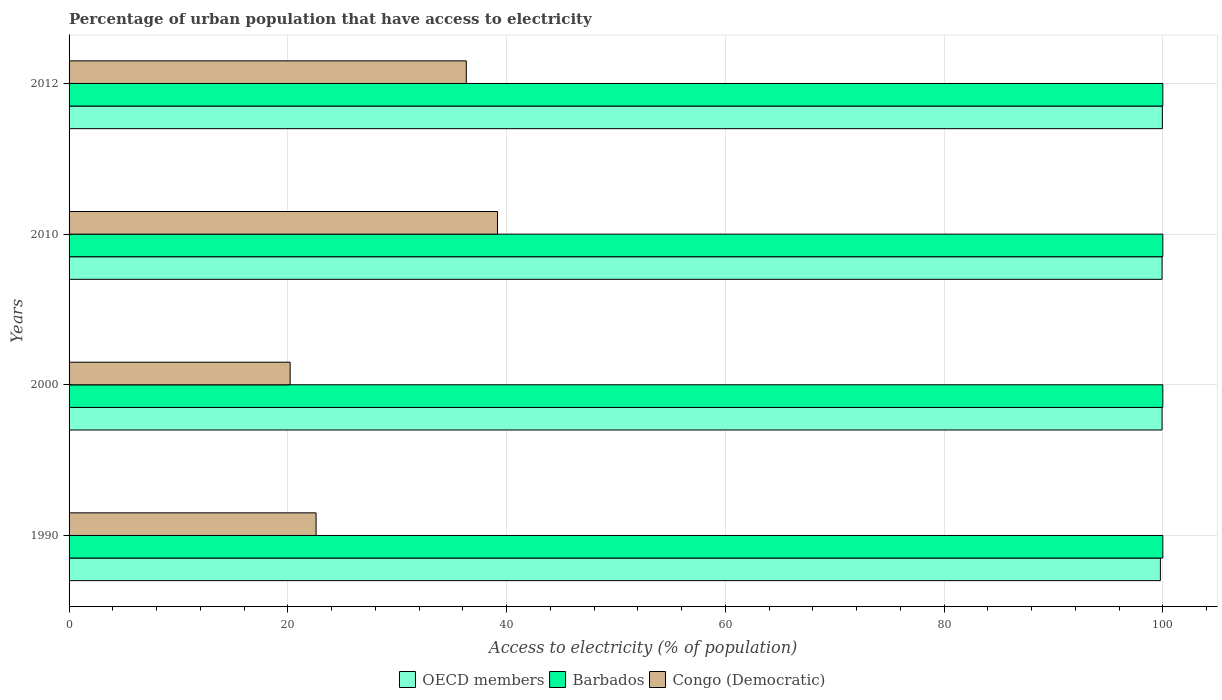How many different coloured bars are there?
Give a very brief answer. 3. How many groups of bars are there?
Your answer should be compact. 4. Are the number of bars per tick equal to the number of legend labels?
Provide a succinct answer. Yes. How many bars are there on the 2nd tick from the top?
Offer a very short reply. 3. What is the label of the 3rd group of bars from the top?
Make the answer very short. 2000. What is the percentage of urban population that have access to electricity in OECD members in 1990?
Make the answer very short. 99.78. Across all years, what is the maximum percentage of urban population that have access to electricity in Barbados?
Offer a terse response. 100. Across all years, what is the minimum percentage of urban population that have access to electricity in Barbados?
Provide a short and direct response. 100. What is the total percentage of urban population that have access to electricity in Congo (Democratic) in the graph?
Provide a short and direct response. 118.29. What is the difference between the percentage of urban population that have access to electricity in Congo (Democratic) in 1990 and that in 2000?
Provide a succinct answer. 2.37. What is the difference between the percentage of urban population that have access to electricity in Congo (Democratic) in 1990 and the percentage of urban population that have access to electricity in Barbados in 2000?
Keep it short and to the point. -77.42. What is the average percentage of urban population that have access to electricity in Congo (Democratic) per year?
Offer a very short reply. 29.57. In the year 2000, what is the difference between the percentage of urban population that have access to electricity in Barbados and percentage of urban population that have access to electricity in Congo (Democratic)?
Offer a very short reply. 79.79. Is the percentage of urban population that have access to electricity in Barbados in 2000 less than that in 2012?
Keep it short and to the point. No. What is the difference between the highest and the second highest percentage of urban population that have access to electricity in OECD members?
Your response must be concise. 0.03. What is the difference between the highest and the lowest percentage of urban population that have access to electricity in OECD members?
Give a very brief answer. 0.18. In how many years, is the percentage of urban population that have access to electricity in Barbados greater than the average percentage of urban population that have access to electricity in Barbados taken over all years?
Ensure brevity in your answer.  0. What does the 2nd bar from the top in 2010 represents?
Your answer should be compact. Barbados. How many bars are there?
Provide a succinct answer. 12. Are all the bars in the graph horizontal?
Your response must be concise. Yes. How many years are there in the graph?
Make the answer very short. 4. What is the difference between two consecutive major ticks on the X-axis?
Your answer should be very brief. 20. Are the values on the major ticks of X-axis written in scientific E-notation?
Your answer should be very brief. No. Does the graph contain any zero values?
Offer a very short reply. No. What is the title of the graph?
Your response must be concise. Percentage of urban population that have access to electricity. What is the label or title of the X-axis?
Your response must be concise. Access to electricity (% of population). What is the Access to electricity (% of population) of OECD members in 1990?
Give a very brief answer. 99.78. What is the Access to electricity (% of population) in Barbados in 1990?
Make the answer very short. 100. What is the Access to electricity (% of population) of Congo (Democratic) in 1990?
Give a very brief answer. 22.58. What is the Access to electricity (% of population) in OECD members in 2000?
Provide a succinct answer. 99.93. What is the Access to electricity (% of population) in Barbados in 2000?
Your response must be concise. 100. What is the Access to electricity (% of population) of Congo (Democratic) in 2000?
Offer a terse response. 20.21. What is the Access to electricity (% of population) of OECD members in 2010?
Your answer should be compact. 99.93. What is the Access to electricity (% of population) in Congo (Democratic) in 2010?
Your answer should be very brief. 39.17. What is the Access to electricity (% of population) of OECD members in 2012?
Ensure brevity in your answer.  99.96. What is the Access to electricity (% of population) in Barbados in 2012?
Offer a terse response. 100. What is the Access to electricity (% of population) of Congo (Democratic) in 2012?
Ensure brevity in your answer.  36.32. Across all years, what is the maximum Access to electricity (% of population) of OECD members?
Ensure brevity in your answer.  99.96. Across all years, what is the maximum Access to electricity (% of population) of Congo (Democratic)?
Keep it short and to the point. 39.17. Across all years, what is the minimum Access to electricity (% of population) of OECD members?
Offer a very short reply. 99.78. Across all years, what is the minimum Access to electricity (% of population) in Barbados?
Your answer should be very brief. 100. Across all years, what is the minimum Access to electricity (% of population) of Congo (Democratic)?
Ensure brevity in your answer.  20.21. What is the total Access to electricity (% of population) of OECD members in the graph?
Provide a short and direct response. 399.6. What is the total Access to electricity (% of population) in Congo (Democratic) in the graph?
Provide a succinct answer. 118.29. What is the difference between the Access to electricity (% of population) of OECD members in 1990 and that in 2000?
Give a very brief answer. -0.15. What is the difference between the Access to electricity (% of population) in Congo (Democratic) in 1990 and that in 2000?
Provide a succinct answer. 2.37. What is the difference between the Access to electricity (% of population) in OECD members in 1990 and that in 2010?
Give a very brief answer. -0.15. What is the difference between the Access to electricity (% of population) in Barbados in 1990 and that in 2010?
Keep it short and to the point. 0. What is the difference between the Access to electricity (% of population) in Congo (Democratic) in 1990 and that in 2010?
Ensure brevity in your answer.  -16.59. What is the difference between the Access to electricity (% of population) of OECD members in 1990 and that in 2012?
Your answer should be very brief. -0.18. What is the difference between the Access to electricity (% of population) in Congo (Democratic) in 1990 and that in 2012?
Provide a short and direct response. -13.73. What is the difference between the Access to electricity (% of population) in OECD members in 2000 and that in 2010?
Keep it short and to the point. -0. What is the difference between the Access to electricity (% of population) in Congo (Democratic) in 2000 and that in 2010?
Ensure brevity in your answer.  -18.96. What is the difference between the Access to electricity (% of population) of OECD members in 2000 and that in 2012?
Offer a very short reply. -0.03. What is the difference between the Access to electricity (% of population) in Barbados in 2000 and that in 2012?
Your answer should be very brief. 0. What is the difference between the Access to electricity (% of population) in Congo (Democratic) in 2000 and that in 2012?
Keep it short and to the point. -16.11. What is the difference between the Access to electricity (% of population) of OECD members in 2010 and that in 2012?
Offer a very short reply. -0.03. What is the difference between the Access to electricity (% of population) in Barbados in 2010 and that in 2012?
Provide a succinct answer. 0. What is the difference between the Access to electricity (% of population) of Congo (Democratic) in 2010 and that in 2012?
Your answer should be very brief. 2.86. What is the difference between the Access to electricity (% of population) of OECD members in 1990 and the Access to electricity (% of population) of Barbados in 2000?
Make the answer very short. -0.22. What is the difference between the Access to electricity (% of population) of OECD members in 1990 and the Access to electricity (% of population) of Congo (Democratic) in 2000?
Your response must be concise. 79.57. What is the difference between the Access to electricity (% of population) of Barbados in 1990 and the Access to electricity (% of population) of Congo (Democratic) in 2000?
Offer a terse response. 79.79. What is the difference between the Access to electricity (% of population) in OECD members in 1990 and the Access to electricity (% of population) in Barbados in 2010?
Provide a short and direct response. -0.22. What is the difference between the Access to electricity (% of population) in OECD members in 1990 and the Access to electricity (% of population) in Congo (Democratic) in 2010?
Keep it short and to the point. 60.61. What is the difference between the Access to electricity (% of population) in Barbados in 1990 and the Access to electricity (% of population) in Congo (Democratic) in 2010?
Provide a short and direct response. 60.83. What is the difference between the Access to electricity (% of population) in OECD members in 1990 and the Access to electricity (% of population) in Barbados in 2012?
Make the answer very short. -0.22. What is the difference between the Access to electricity (% of population) of OECD members in 1990 and the Access to electricity (% of population) of Congo (Democratic) in 2012?
Offer a terse response. 63.46. What is the difference between the Access to electricity (% of population) in Barbados in 1990 and the Access to electricity (% of population) in Congo (Democratic) in 2012?
Provide a short and direct response. 63.68. What is the difference between the Access to electricity (% of population) of OECD members in 2000 and the Access to electricity (% of population) of Barbados in 2010?
Give a very brief answer. -0.07. What is the difference between the Access to electricity (% of population) in OECD members in 2000 and the Access to electricity (% of population) in Congo (Democratic) in 2010?
Offer a terse response. 60.76. What is the difference between the Access to electricity (% of population) in Barbados in 2000 and the Access to electricity (% of population) in Congo (Democratic) in 2010?
Ensure brevity in your answer.  60.83. What is the difference between the Access to electricity (% of population) in OECD members in 2000 and the Access to electricity (% of population) in Barbados in 2012?
Make the answer very short. -0.07. What is the difference between the Access to electricity (% of population) in OECD members in 2000 and the Access to electricity (% of population) in Congo (Democratic) in 2012?
Ensure brevity in your answer.  63.61. What is the difference between the Access to electricity (% of population) of Barbados in 2000 and the Access to electricity (% of population) of Congo (Democratic) in 2012?
Offer a terse response. 63.68. What is the difference between the Access to electricity (% of population) of OECD members in 2010 and the Access to electricity (% of population) of Barbados in 2012?
Offer a very short reply. -0.07. What is the difference between the Access to electricity (% of population) of OECD members in 2010 and the Access to electricity (% of population) of Congo (Democratic) in 2012?
Give a very brief answer. 63.62. What is the difference between the Access to electricity (% of population) of Barbados in 2010 and the Access to electricity (% of population) of Congo (Democratic) in 2012?
Make the answer very short. 63.68. What is the average Access to electricity (% of population) in OECD members per year?
Your response must be concise. 99.9. What is the average Access to electricity (% of population) of Congo (Democratic) per year?
Provide a succinct answer. 29.57. In the year 1990, what is the difference between the Access to electricity (% of population) in OECD members and Access to electricity (% of population) in Barbados?
Ensure brevity in your answer.  -0.22. In the year 1990, what is the difference between the Access to electricity (% of population) in OECD members and Access to electricity (% of population) in Congo (Democratic)?
Your response must be concise. 77.19. In the year 1990, what is the difference between the Access to electricity (% of population) of Barbados and Access to electricity (% of population) of Congo (Democratic)?
Keep it short and to the point. 77.42. In the year 2000, what is the difference between the Access to electricity (% of population) in OECD members and Access to electricity (% of population) in Barbados?
Provide a succinct answer. -0.07. In the year 2000, what is the difference between the Access to electricity (% of population) in OECD members and Access to electricity (% of population) in Congo (Democratic)?
Make the answer very short. 79.72. In the year 2000, what is the difference between the Access to electricity (% of population) in Barbados and Access to electricity (% of population) in Congo (Democratic)?
Provide a short and direct response. 79.79. In the year 2010, what is the difference between the Access to electricity (% of population) of OECD members and Access to electricity (% of population) of Barbados?
Your answer should be very brief. -0.07. In the year 2010, what is the difference between the Access to electricity (% of population) of OECD members and Access to electricity (% of population) of Congo (Democratic)?
Provide a short and direct response. 60.76. In the year 2010, what is the difference between the Access to electricity (% of population) of Barbados and Access to electricity (% of population) of Congo (Democratic)?
Keep it short and to the point. 60.83. In the year 2012, what is the difference between the Access to electricity (% of population) in OECD members and Access to electricity (% of population) in Barbados?
Make the answer very short. -0.04. In the year 2012, what is the difference between the Access to electricity (% of population) in OECD members and Access to electricity (% of population) in Congo (Democratic)?
Provide a short and direct response. 63.64. In the year 2012, what is the difference between the Access to electricity (% of population) in Barbados and Access to electricity (% of population) in Congo (Democratic)?
Give a very brief answer. 63.68. What is the ratio of the Access to electricity (% of population) of OECD members in 1990 to that in 2000?
Keep it short and to the point. 1. What is the ratio of the Access to electricity (% of population) of Congo (Democratic) in 1990 to that in 2000?
Offer a terse response. 1.12. What is the ratio of the Access to electricity (% of population) of Barbados in 1990 to that in 2010?
Give a very brief answer. 1. What is the ratio of the Access to electricity (% of population) in Congo (Democratic) in 1990 to that in 2010?
Your response must be concise. 0.58. What is the ratio of the Access to electricity (% of population) of OECD members in 1990 to that in 2012?
Make the answer very short. 1. What is the ratio of the Access to electricity (% of population) in Barbados in 1990 to that in 2012?
Your answer should be compact. 1. What is the ratio of the Access to electricity (% of population) of Congo (Democratic) in 1990 to that in 2012?
Offer a terse response. 0.62. What is the ratio of the Access to electricity (% of population) of OECD members in 2000 to that in 2010?
Offer a terse response. 1. What is the ratio of the Access to electricity (% of population) in Congo (Democratic) in 2000 to that in 2010?
Your answer should be very brief. 0.52. What is the ratio of the Access to electricity (% of population) of Barbados in 2000 to that in 2012?
Make the answer very short. 1. What is the ratio of the Access to electricity (% of population) of Congo (Democratic) in 2000 to that in 2012?
Offer a very short reply. 0.56. What is the ratio of the Access to electricity (% of population) of OECD members in 2010 to that in 2012?
Offer a terse response. 1. What is the ratio of the Access to electricity (% of population) in Congo (Democratic) in 2010 to that in 2012?
Your answer should be compact. 1.08. What is the difference between the highest and the second highest Access to electricity (% of population) of OECD members?
Make the answer very short. 0.03. What is the difference between the highest and the second highest Access to electricity (% of population) in Barbados?
Your response must be concise. 0. What is the difference between the highest and the second highest Access to electricity (% of population) of Congo (Democratic)?
Offer a very short reply. 2.86. What is the difference between the highest and the lowest Access to electricity (% of population) of OECD members?
Your answer should be very brief. 0.18. What is the difference between the highest and the lowest Access to electricity (% of population) in Barbados?
Keep it short and to the point. 0. What is the difference between the highest and the lowest Access to electricity (% of population) in Congo (Democratic)?
Offer a very short reply. 18.96. 